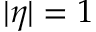Convert formula to latex. <formula><loc_0><loc_0><loc_500><loc_500>| \eta | = 1</formula> 